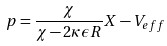<formula> <loc_0><loc_0><loc_500><loc_500>p = \frac { \chi } { \chi - 2 \kappa \epsilon R } X - V _ { e f f }</formula> 